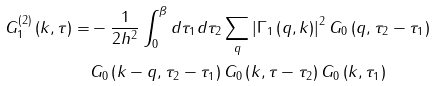<formula> <loc_0><loc_0><loc_500><loc_500>G _ { 1 } ^ { \left ( 2 \right ) } \left ( k , \tau \right ) = & - \frac { 1 } { 2 h ^ { 2 } } \int _ { 0 } ^ { \beta } d \tau _ { 1 } d \tau _ { 2 } \sum _ { q } \left | \Gamma _ { 1 } \left ( q , k \right ) \right | ^ { 2 } G _ { 0 } \left ( q , \tau _ { 2 } - \tau _ { 1 } \right ) \\ & G _ { 0 } \left ( k - q , \tau _ { 2 } - \tau _ { 1 } \right ) G _ { 0 } \left ( k , \tau - \tau _ { 2 } \right ) G _ { 0 } \left ( k , \tau _ { 1 } \right )</formula> 